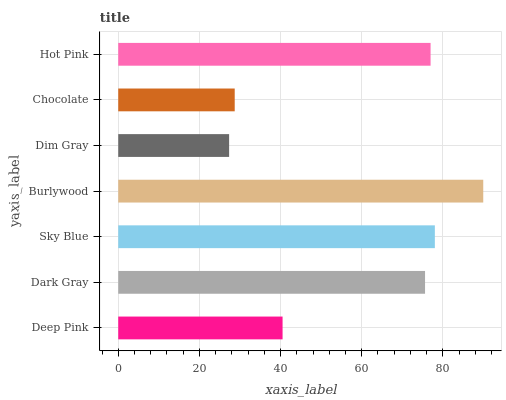Is Dim Gray the minimum?
Answer yes or no. Yes. Is Burlywood the maximum?
Answer yes or no. Yes. Is Dark Gray the minimum?
Answer yes or no. No. Is Dark Gray the maximum?
Answer yes or no. No. Is Dark Gray greater than Deep Pink?
Answer yes or no. Yes. Is Deep Pink less than Dark Gray?
Answer yes or no. Yes. Is Deep Pink greater than Dark Gray?
Answer yes or no. No. Is Dark Gray less than Deep Pink?
Answer yes or no. No. Is Dark Gray the high median?
Answer yes or no. Yes. Is Dark Gray the low median?
Answer yes or no. Yes. Is Hot Pink the high median?
Answer yes or no. No. Is Deep Pink the low median?
Answer yes or no. No. 